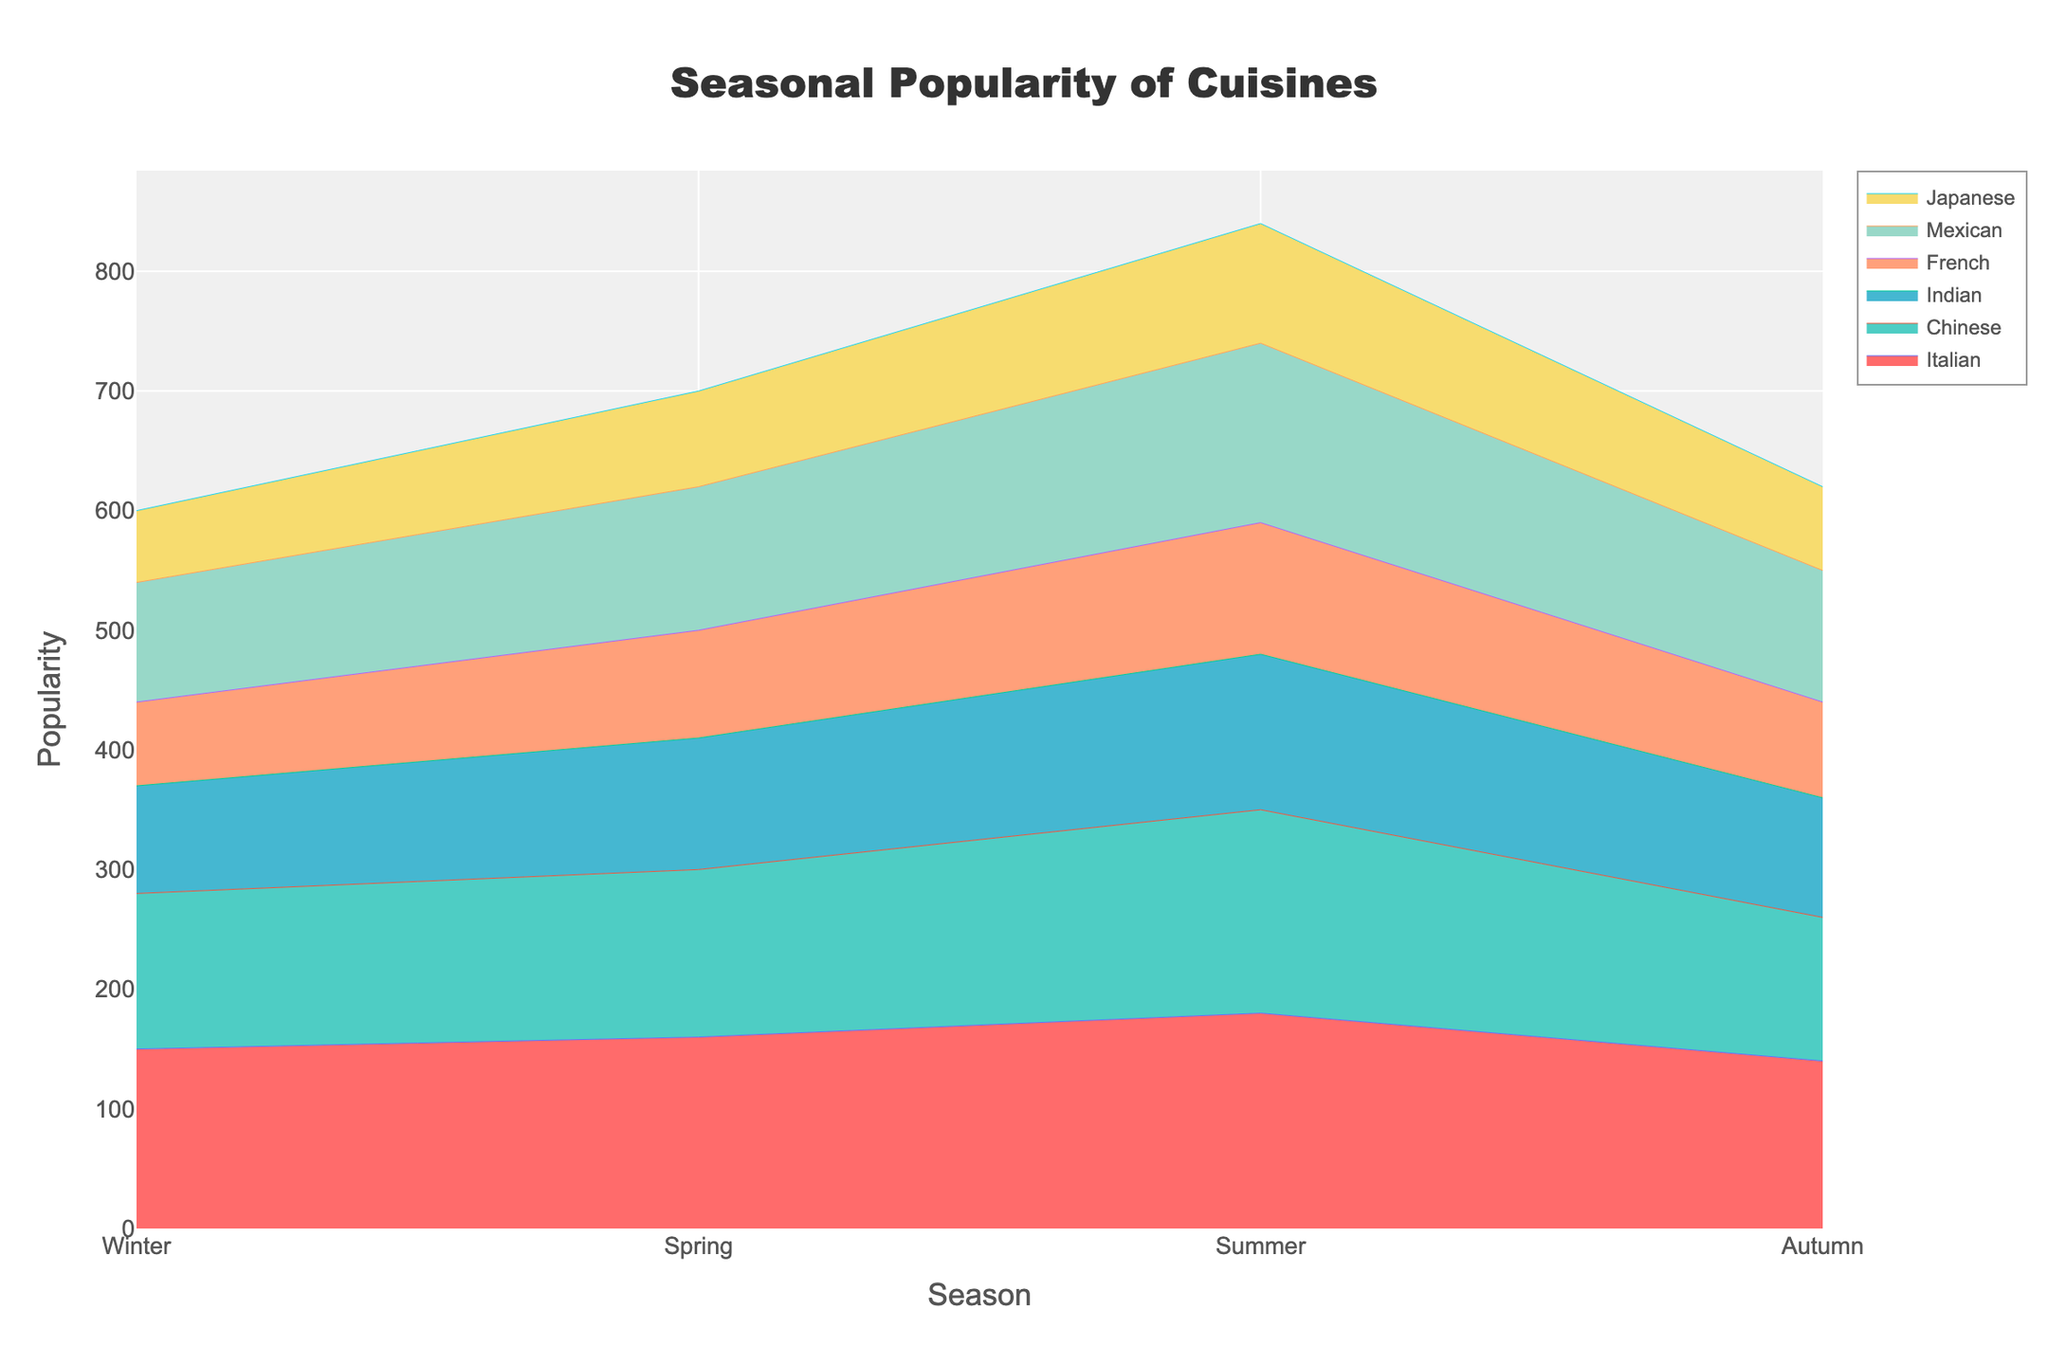When is Italian cuisine the most popular? Italian cuisine is the most popular during the summer season. This is determined by looking at the line corresponding to Italian cuisine and observing that it peaks in the summer.
Answer: Summer Which cuisine shows the least seasonal variation? The Japanese cuisine shows the least seasonal variation. It maintains relatively low but consistent popularity across different seasons, as indicated by the relatively flat line.
Answer: Japanese What's the total popularity of all cuisines in the spring? Sum the popularity values for all cuisines in the spring: 160 (Italian) + 140 (Chinese) + 110 (Indian) + 90 (French) + 120 (Mexican) + 80 (Japanese) = 700.
Answer: 700 In which season is Mexican cuisine more popular than Italian? Mexican cuisine is never more popular than Italian in any season. By comparing the Mexican and Italian lines across all seasons, the Italian cuisine line is always higher than the Mexican cuisine line.
Answer: Never Which cuisines see a decline in popularity from summer to autumn? By comparing the popularity lines from summer to autumn, Italian, Chinese, Indian, French, Mexican, and Japanese cuisines all see a decline in popularity as each line shows a decrease from summer to autumn.
Answer: All (Italian, Chinese, Indian, French, Mexican, Japanese) Which season has the highest total popularity of all cuisines combined? Sum the popularity values of all cuisines for each season:
- Winter: 150 + 130 + 90 + 70 + 100 + 60 = 600
- Spring: 160 + 140 + 110 + 90 + 120 + 80 = 700
- Summer: 180 + 170 + 130 + 110 + 150 + 100 = 840
- Autumn: 140 + 120 + 100 + 80 + 110 + 70 = 620
Summer has the highest total popularity of 840.
Answer: Summer How does the popularity of French cuisine change across the seasons? Observing the line corresponding to French cuisine:
- Winter: 70
- Spring: 90 (increase from winter)
- Summer: 110 (increase from spring)
- Autumn: 80 (decrease from summer)
French cuisine's popularity increases from winter to summer and then decreases in autumn.
Answer: Increases from winter to summer, then decreases in autumn Which cuisine has the highest popularity value in any single season, and what is that value? Looking at all the lines across all seasons, Italian cuisine in summer holds the highest popularity value, which is 180.
Answer: Italian in summer, 180 What's the average popularity of Indian cuisine across all seasons? Sum the popularity values for Indian cuisine in all seasons: 90 (Winter) + 110 (Spring) + 130 (Summer) + 100 (Autumn) = 430. The average is 430 / 4 = 107.5.
Answer: 107.5 Which seasons show an upward trend for Chinese cuisine? By observing the line for Chinese cuisine:
- Winter to Spring: 130 to 140 (upward)
- Spring to Summer: 140 to 170 (upward)
- Summer to Autumn: 170 to 120 (downward)
Chinese cuisine shows an upward trend from winter to summer.
Answer: Winter to Summer 